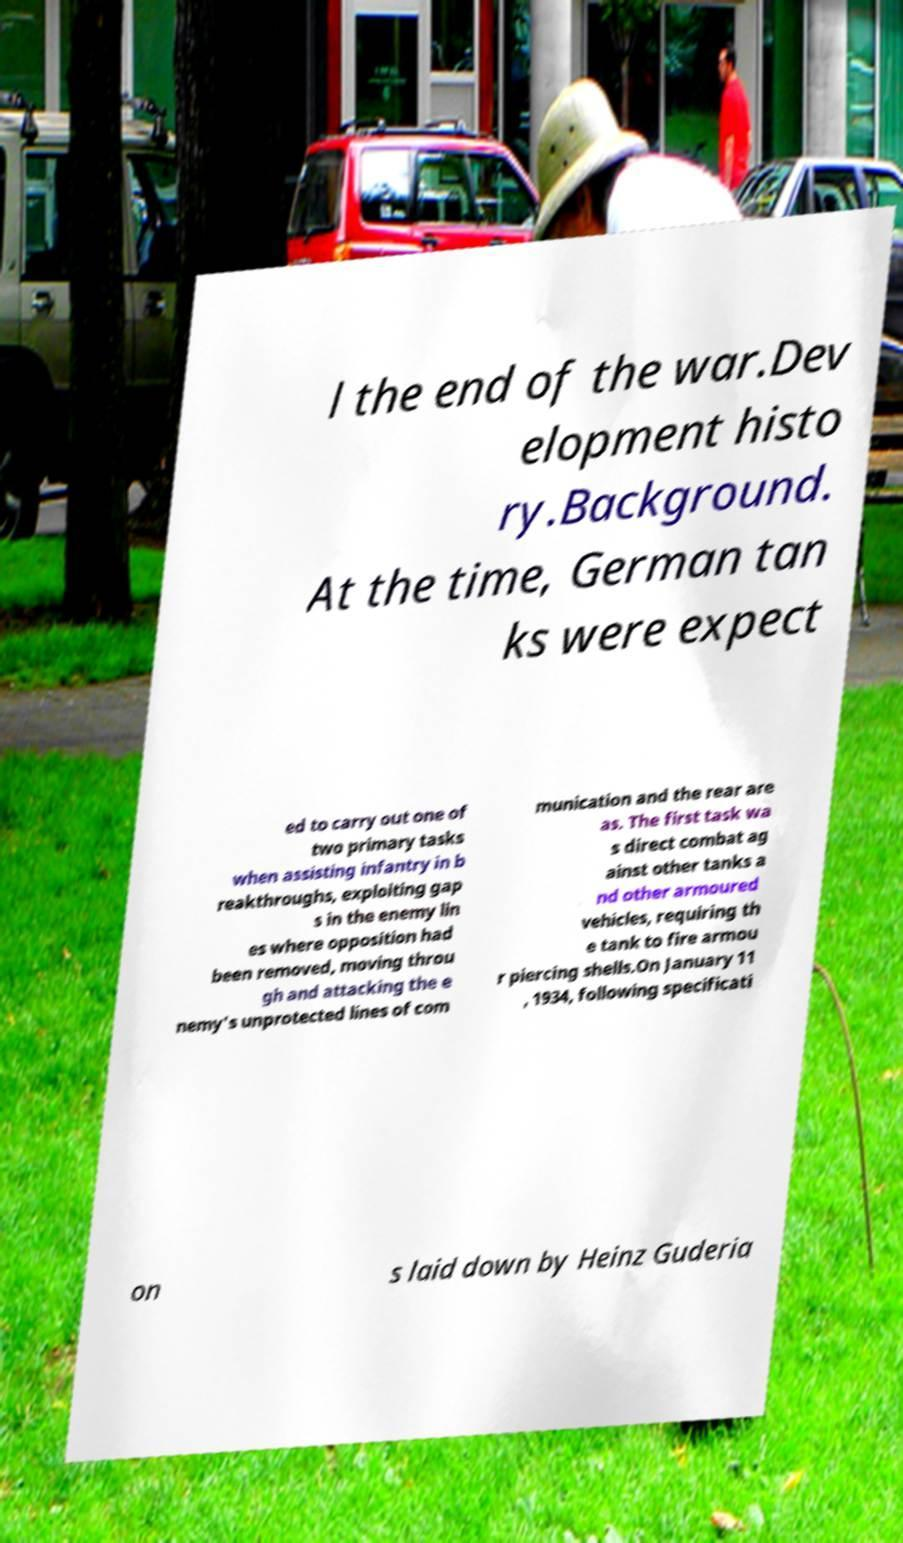Could you extract and type out the text from this image? l the end of the war.Dev elopment histo ry.Background. At the time, German tan ks were expect ed to carry out one of two primary tasks when assisting infantry in b reakthroughs, exploiting gap s in the enemy lin es where opposition had been removed, moving throu gh and attacking the e nemy's unprotected lines of com munication and the rear are as. The first task wa s direct combat ag ainst other tanks a nd other armoured vehicles, requiring th e tank to fire armou r piercing shells.On January 11 , 1934, following specificati on s laid down by Heinz Guderia 